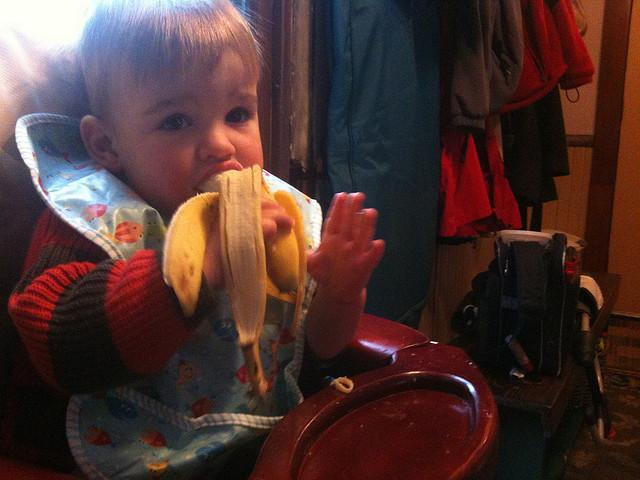Why is he wearing a bib? eating 